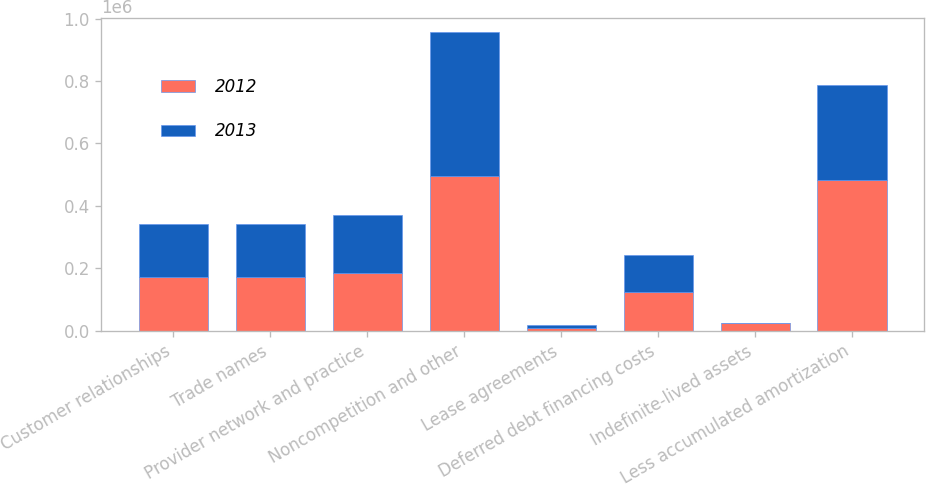<chart> <loc_0><loc_0><loc_500><loc_500><stacked_bar_chart><ecel><fcel>Customer relationships<fcel>Trade names<fcel>Provider network and practice<fcel>Noncompetition and other<fcel>Lease agreements<fcel>Deferred debt financing costs<fcel>Indefinite-lived assets<fcel>Less accumulated amortization<nl><fcel>2012<fcel>170744<fcel>170994<fcel>184558<fcel>495475<fcel>8889<fcel>121872<fcel>22932<fcel>483773<nl><fcel>2013<fcel>170744<fcel>170494<fcel>184264<fcel>460011<fcel>9574<fcel>121176<fcel>762<fcel>304323<nl></chart> 